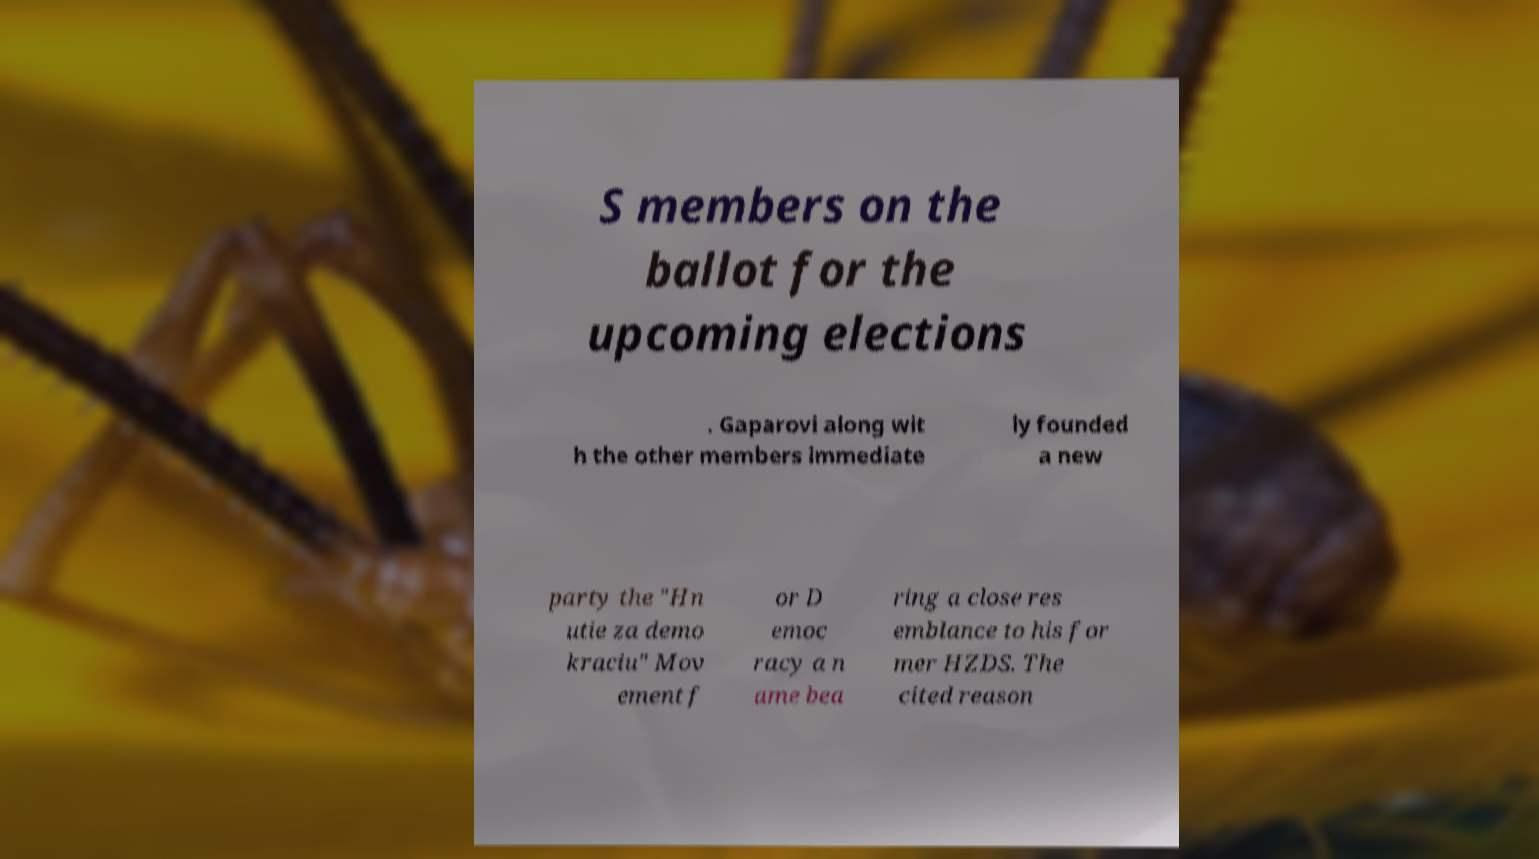I need the written content from this picture converted into text. Can you do that? S members on the ballot for the upcoming elections . Gaparovi along wit h the other members immediate ly founded a new party the "Hn utie za demo kraciu" Mov ement f or D emoc racy a n ame bea ring a close res emblance to his for mer HZDS. The cited reason 